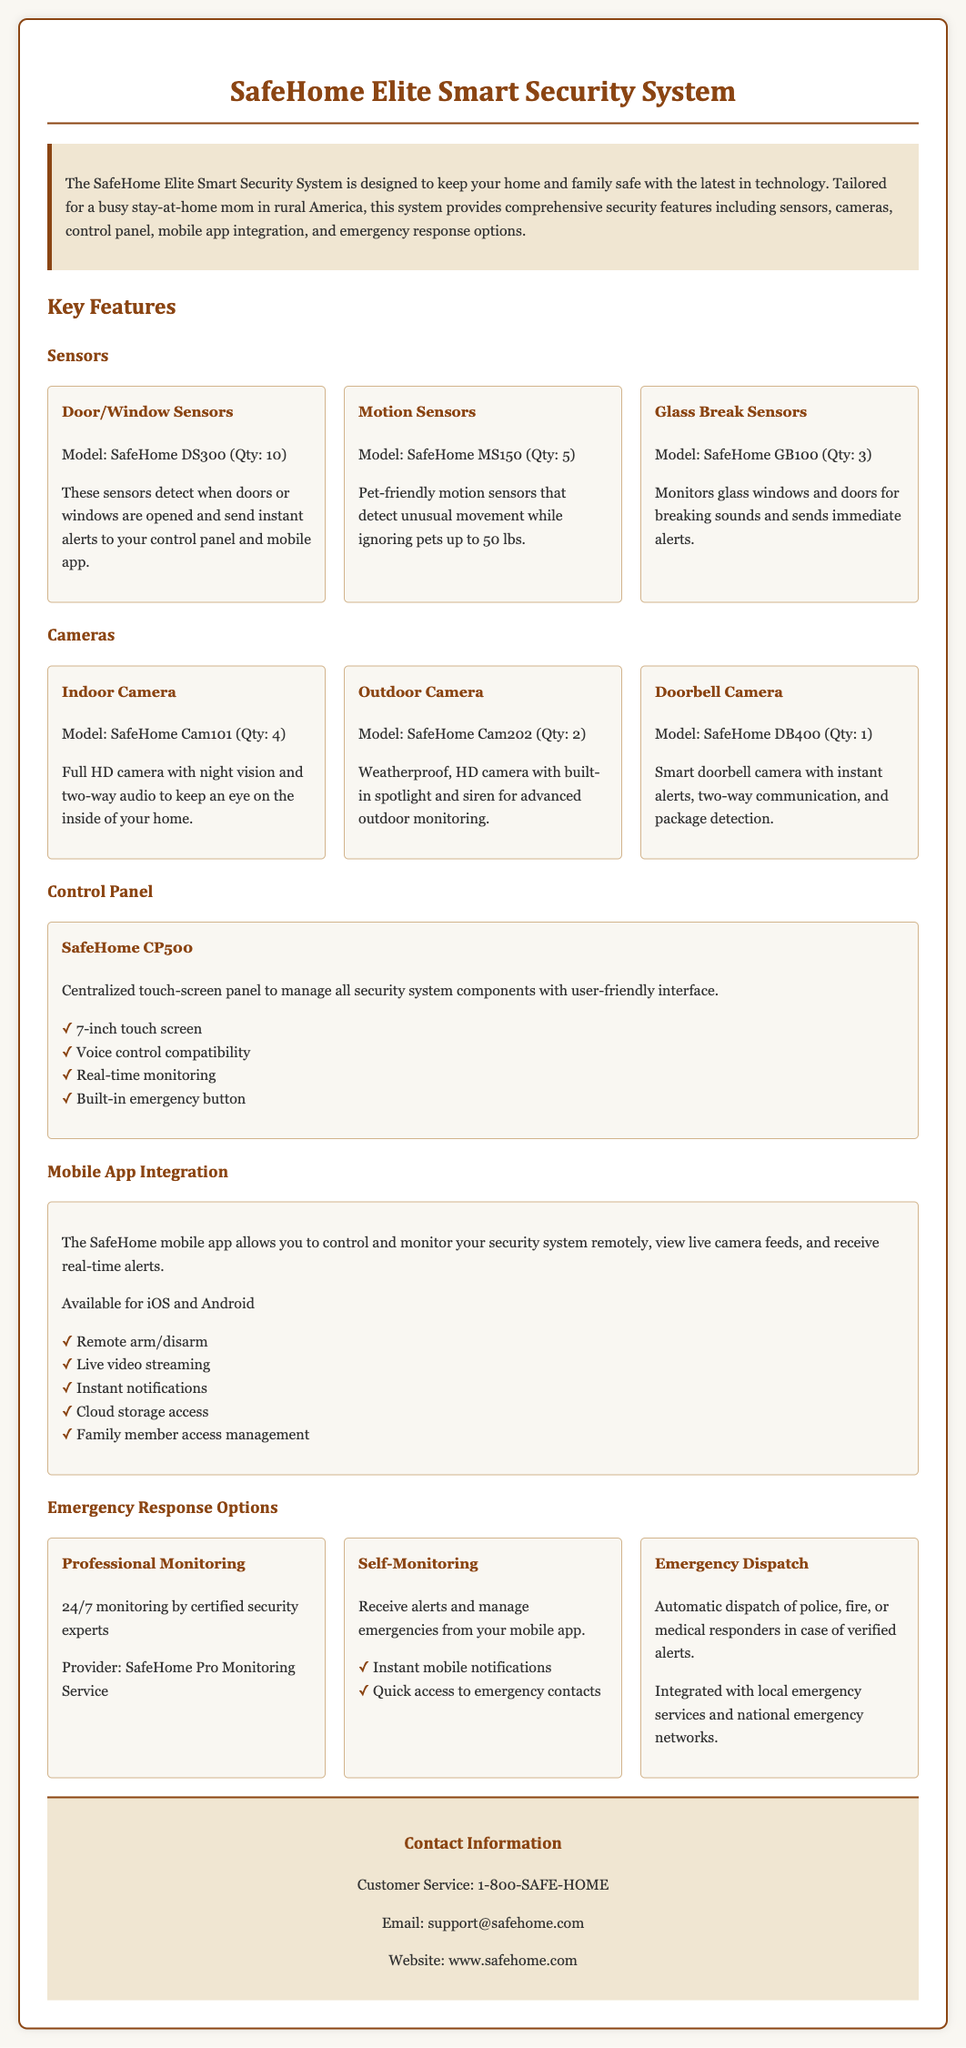what is the model of the indoor camera? The document specifies the indoor camera's model as SafeHome Cam101.
Answer: SafeHome Cam101 how many door/window sensors are included? The document states that there are 10 door/window sensors included in the system.
Answer: 10 what kind of monitoring is provided by SafeHome Pro Monitoring Service? The document mentions that the monitoring is performed 24/7 by certified security experts.
Answer: 24/7 which mobile operating systems support the SafeHome app? The document indicates that the SafeHome mobile app is available for iOS and Android.
Answer: iOS and Android how many outdoor cameras are provided? According to the document, there are 2 outdoor cameras included in the system.
Answer: 2 what feature does the control panel offer for emergencies? The document states that the control panel has a built-in emergency button.
Answer: Built-in emergency button what is the maximum weight that motion sensors ignore? The document mentions that the motion sensors ignore pets up to 50 lbs in weight.
Answer: 50 lbs what type of response is included with automatic dispatch? The document explains that automatic dispatch sends police, fire, or medical responders in case of verified alerts.
Answer: Police, fire, or medical responders 